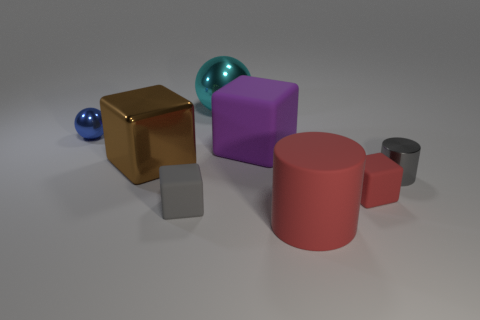Add 1 brown rubber balls. How many objects exist? 9 Subtract all cylinders. How many objects are left? 6 Subtract 0 cyan cylinders. How many objects are left? 8 Subtract all big cubes. Subtract all rubber cylinders. How many objects are left? 5 Add 8 large balls. How many large balls are left? 9 Add 5 blocks. How many blocks exist? 9 